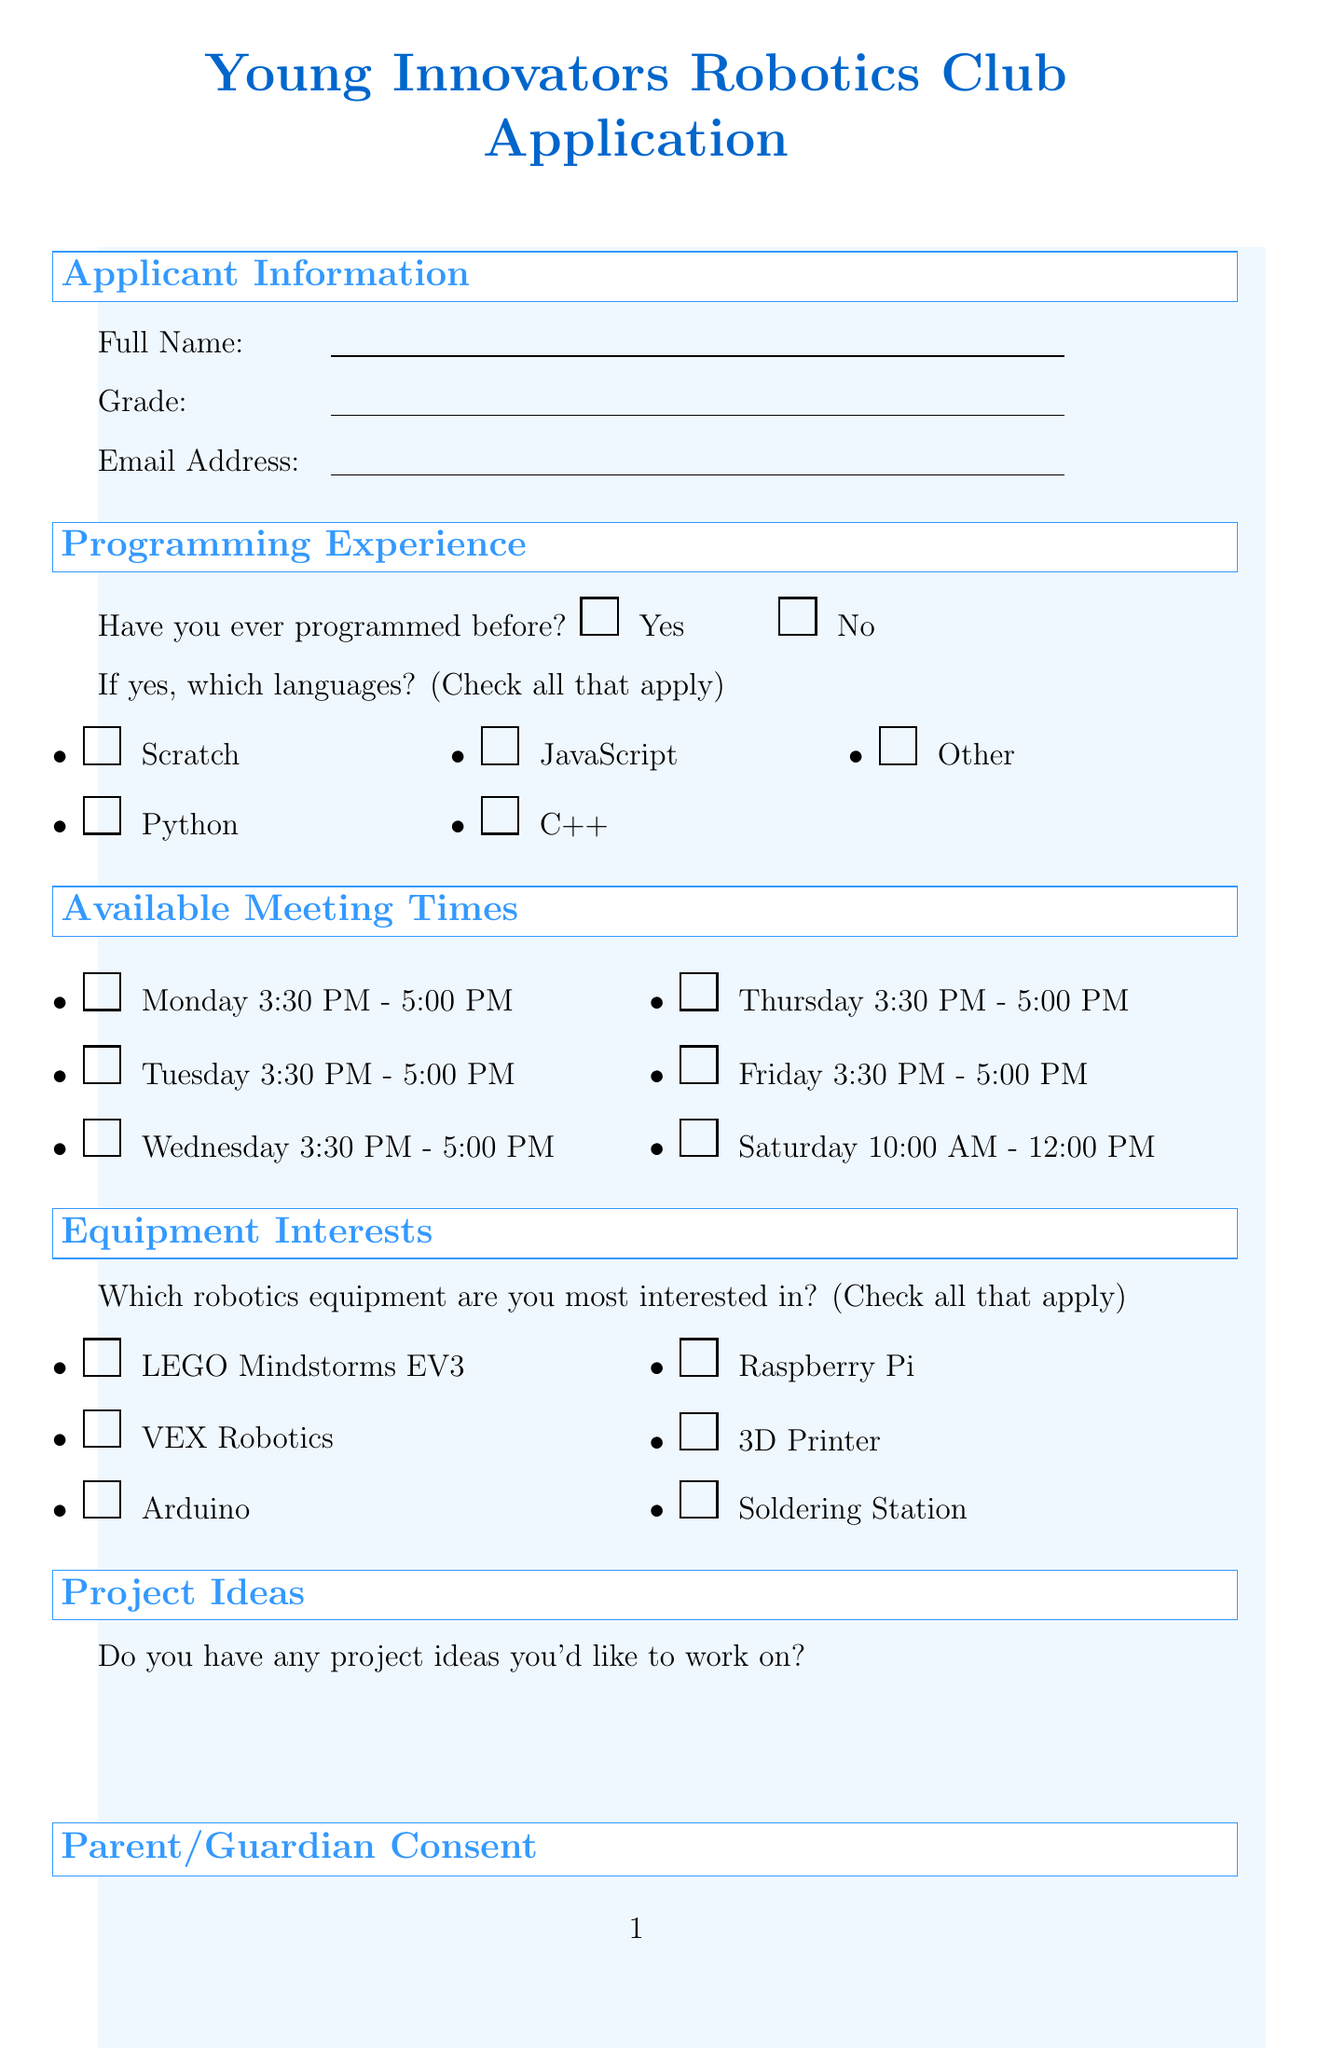what is the title of the form? The title of the form is prominently displayed at the top of the document.
Answer: Young Innovators Robotics Club Application how many options does the applicant have for their grade? The dropdown for grades includes a specific count of options listed.
Answer: 5 which programming languages can be selected if the applicant has programmed before? The document lists multiple programming languages that can be checked in case a programmer has prior experience.
Answer: Scratch, Python, JavaScript, C++, Other what is the time slot available on Saturday? The scheduled meeting time for Saturday is mentioned clearly in the available times section of the document.
Answer: 10:00 AM - 12:00 PM what is required from the parent/guardian for consent? The document specifies a checkbox statement that signifies permission from the parent or guardian.
Answer: I give permission for my child to join the robotics club how must the applicant express any additional information? The document provides a specific section dedicated to gather any further insights about the applicant's interests.
Answer: Text area 